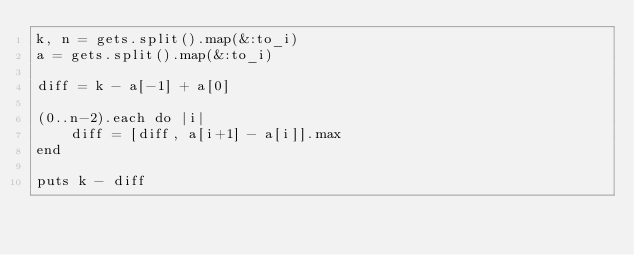Convert code to text. <code><loc_0><loc_0><loc_500><loc_500><_Ruby_>k, n = gets.split().map(&:to_i)
a = gets.split().map(&:to_i)

diff = k - a[-1] + a[0]

(0..n-2).each do |i|
    diff = [diff, a[i+1] - a[i]].max
end

puts k - diff</code> 